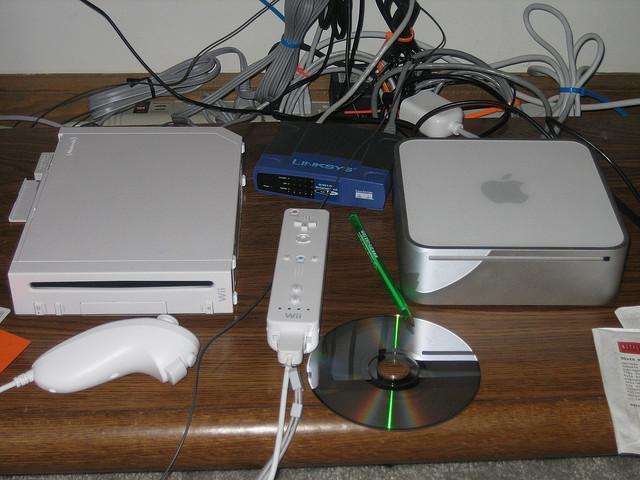How many remotes are in the photo?
Give a very brief answer. 2. 